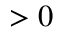<formula> <loc_0><loc_0><loc_500><loc_500>> 0</formula> 